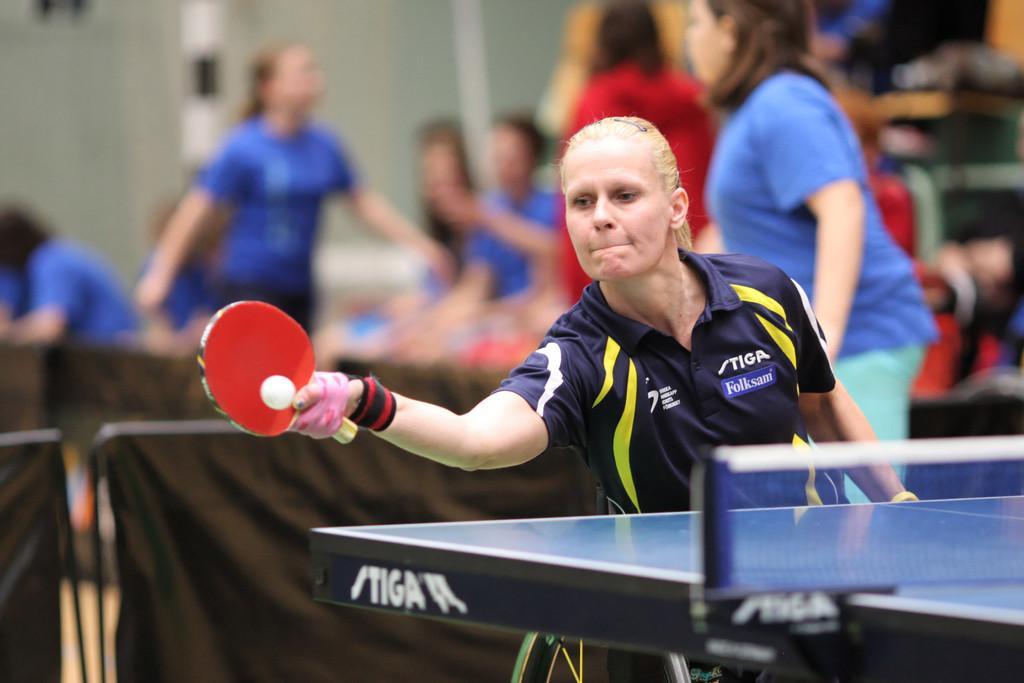Please provide a concise description of this image. In this image there is a woman playing a table tennis. 